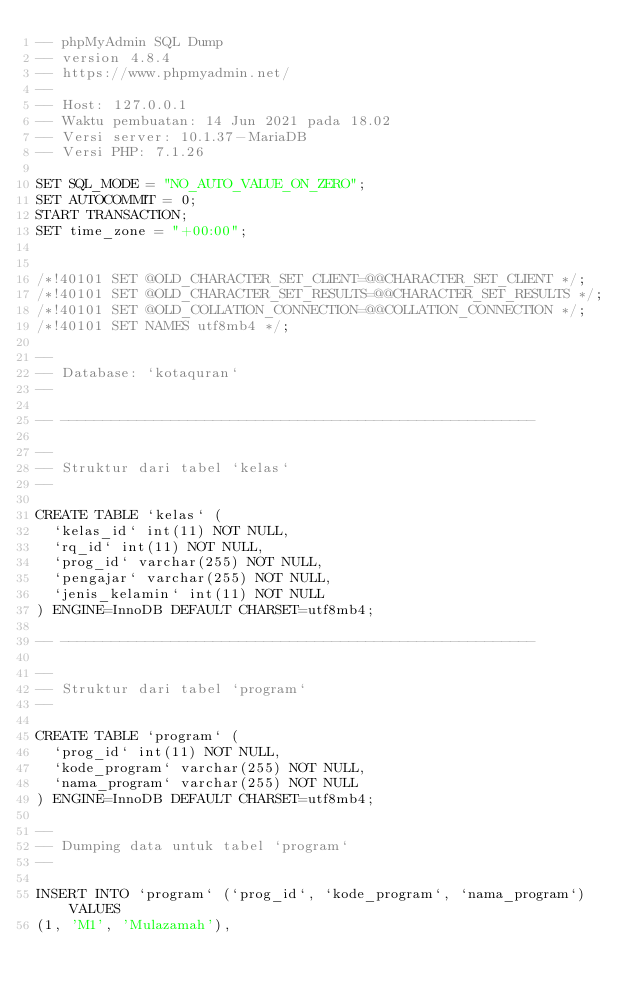Convert code to text. <code><loc_0><loc_0><loc_500><loc_500><_SQL_>-- phpMyAdmin SQL Dump
-- version 4.8.4
-- https://www.phpmyadmin.net/
--
-- Host: 127.0.0.1
-- Waktu pembuatan: 14 Jun 2021 pada 18.02
-- Versi server: 10.1.37-MariaDB
-- Versi PHP: 7.1.26

SET SQL_MODE = "NO_AUTO_VALUE_ON_ZERO";
SET AUTOCOMMIT = 0;
START TRANSACTION;
SET time_zone = "+00:00";


/*!40101 SET @OLD_CHARACTER_SET_CLIENT=@@CHARACTER_SET_CLIENT */;
/*!40101 SET @OLD_CHARACTER_SET_RESULTS=@@CHARACTER_SET_RESULTS */;
/*!40101 SET @OLD_COLLATION_CONNECTION=@@COLLATION_CONNECTION */;
/*!40101 SET NAMES utf8mb4 */;

--
-- Database: `kotaquran`
--

-- --------------------------------------------------------

--
-- Struktur dari tabel `kelas`
--

CREATE TABLE `kelas` (
  `kelas_id` int(11) NOT NULL,
  `rq_id` int(11) NOT NULL,
  `prog_id` varchar(255) NOT NULL,
  `pengajar` varchar(255) NOT NULL,
  `jenis_kelamin` int(11) NOT NULL
) ENGINE=InnoDB DEFAULT CHARSET=utf8mb4;

-- --------------------------------------------------------

--
-- Struktur dari tabel `program`
--

CREATE TABLE `program` (
  `prog_id` int(11) NOT NULL,
  `kode_program` varchar(255) NOT NULL,
  `nama_program` varchar(255) NOT NULL
) ENGINE=InnoDB DEFAULT CHARSET=utf8mb4;

--
-- Dumping data untuk tabel `program`
--

INSERT INTO `program` (`prog_id`, `kode_program`, `nama_program`) VALUES
(1, 'M1', 'Mulazamah'),</code> 